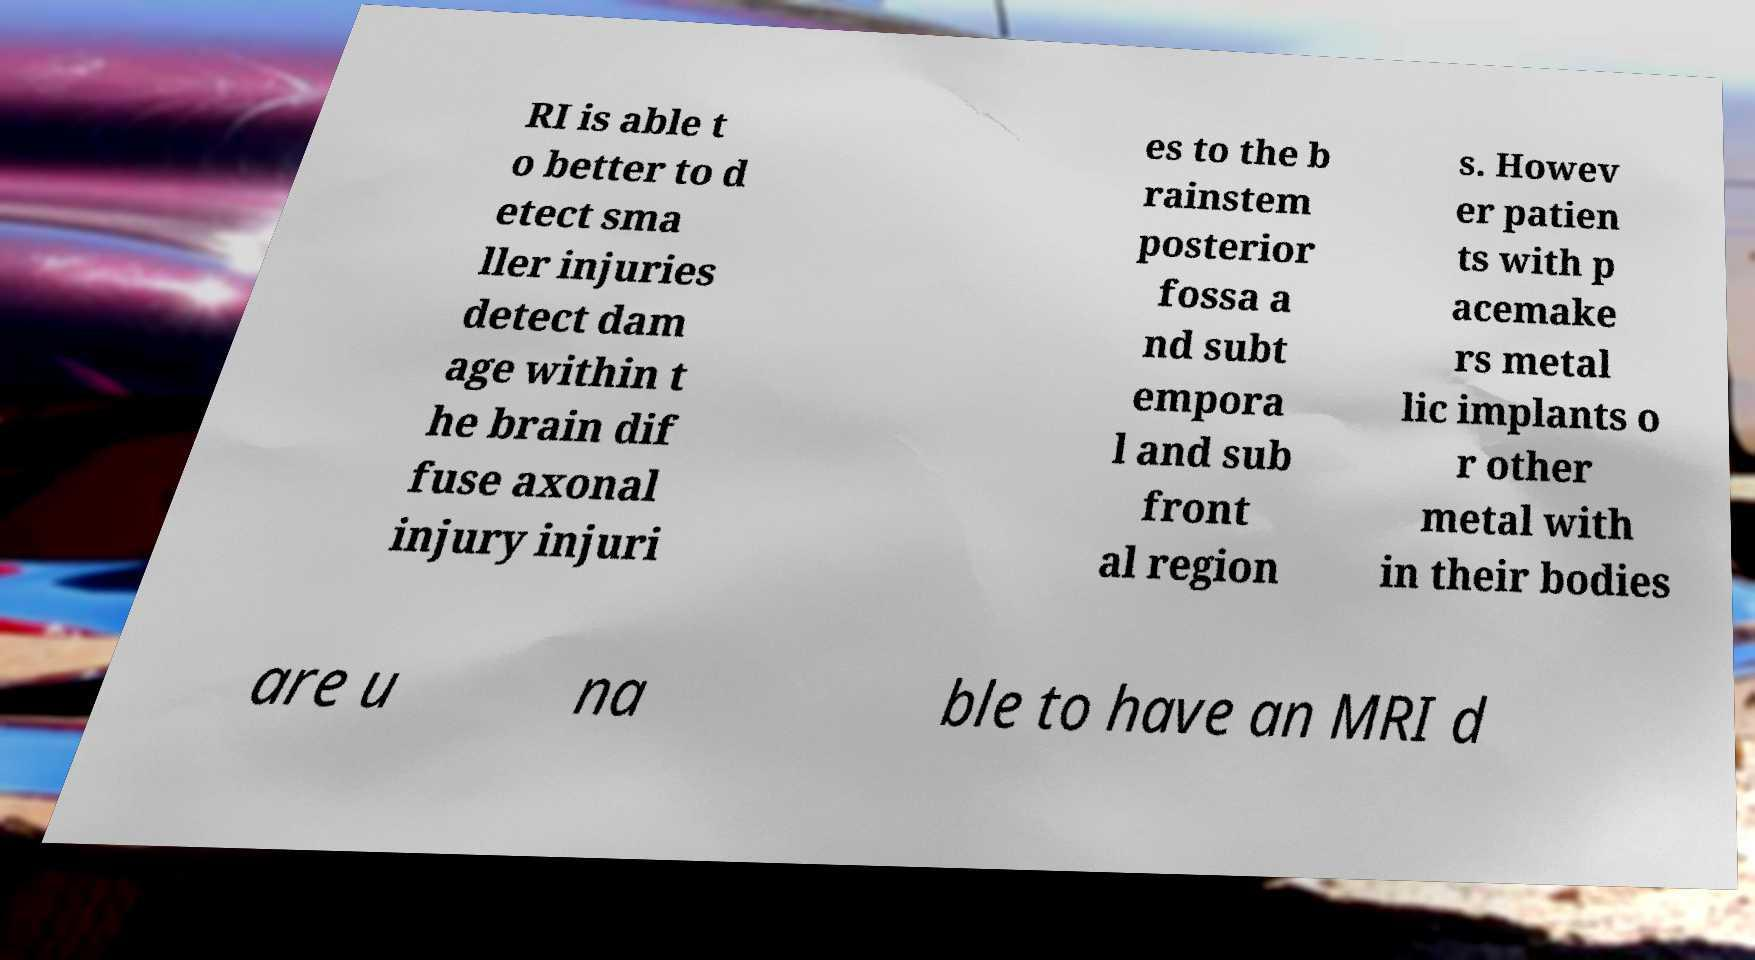There's text embedded in this image that I need extracted. Can you transcribe it verbatim? RI is able t o better to d etect sma ller injuries detect dam age within t he brain dif fuse axonal injury injuri es to the b rainstem posterior fossa a nd subt empora l and sub front al region s. Howev er patien ts with p acemake rs metal lic implants o r other metal with in their bodies are u na ble to have an MRI d 